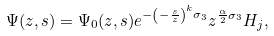Convert formula to latex. <formula><loc_0><loc_0><loc_500><loc_500>\Psi ( z , s ) = \Psi _ { 0 } ( z , s ) e ^ { - \left ( - \frac { s } { z } \right ) ^ { k } \sigma _ { 3 } } z ^ { \frac { \alpha } { 2 } \sigma _ { 3 } } H _ { j } ,</formula> 